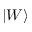Convert formula to latex. <formula><loc_0><loc_0><loc_500><loc_500>\left | W \right \rangle</formula> 